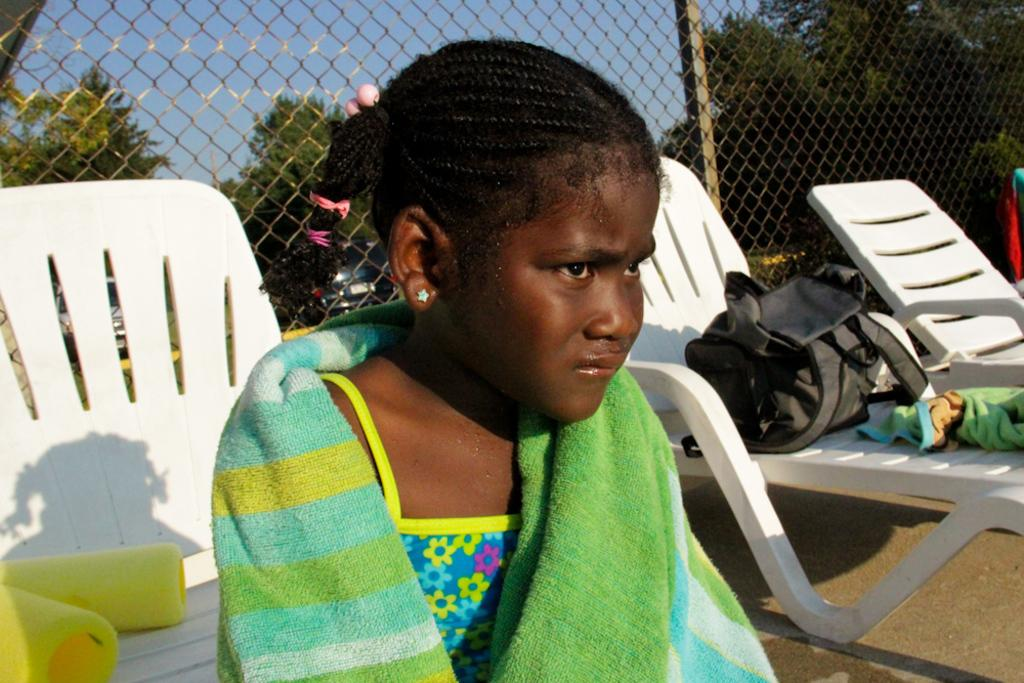Who is the main subject in the image? There is a girl in the image. What is the girl doing in the image? The girl is sitting on a chair. What type of joke is the girl telling in the image? There is no indication in the image that the girl is telling a joke, as the facts provided only mention her sitting on a chair. 